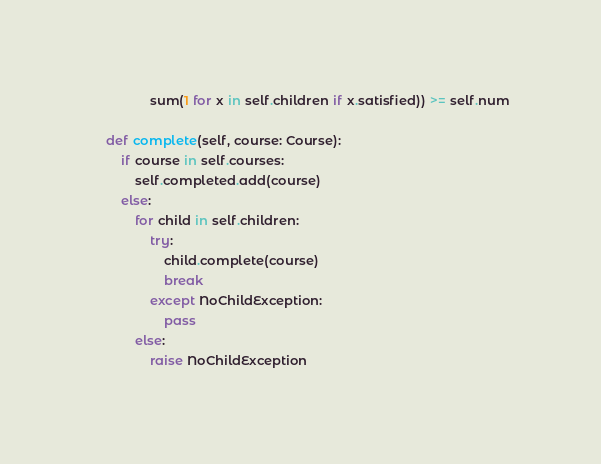<code> <loc_0><loc_0><loc_500><loc_500><_Python_>                sum(1 for x in self.children if x.satisfied)) >= self.num

    def complete(self, course: Course):
        if course in self.courses:
            self.completed.add(course)
        else:
            for child in self.children:
                try:
                    child.complete(course)
                    break
                except NoChildException:
                    pass
            else:
                raise NoChildException

</code> 